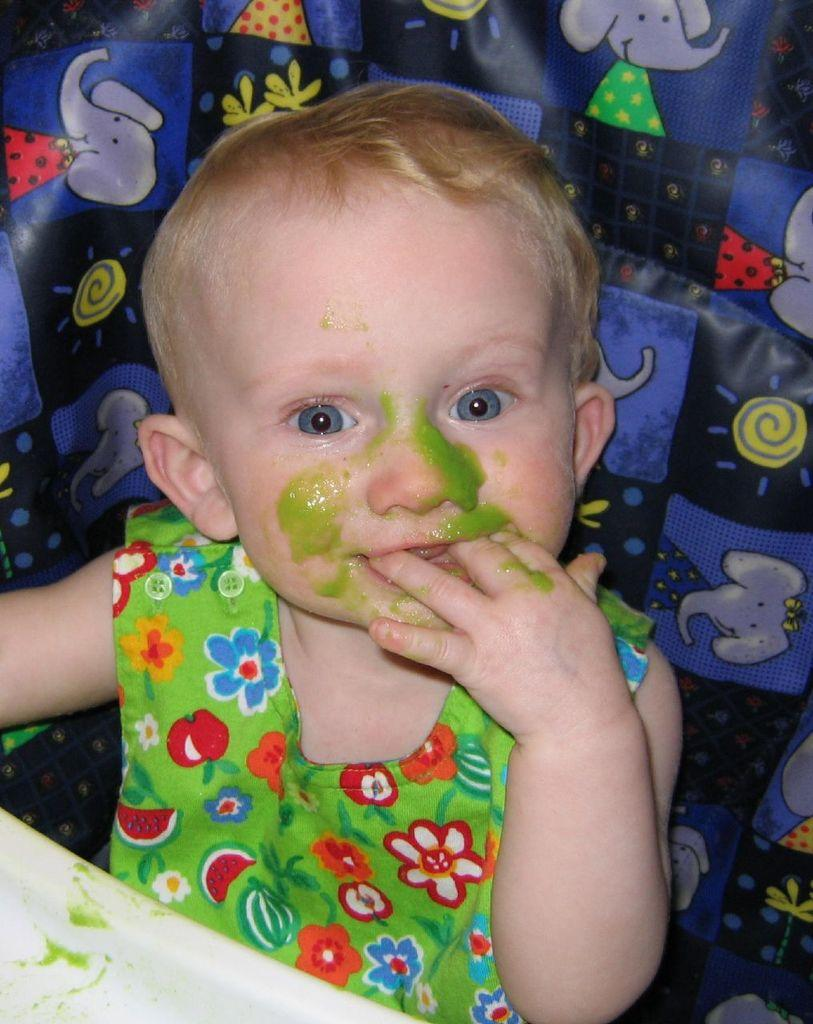Who is the main subject in the image? There is a girl in the image. What is the girl wearing? The girl is wearing a green shirt. What is the girl doing in the image? The girl is sitting on a chair. What is in front of the girl on the table? There is a white plate in front of the girl. What is on the girl's face? The girl has green sauce on her face. What type of blade is the girl using to cut the net in the image? There is no blade or net present in the image. 